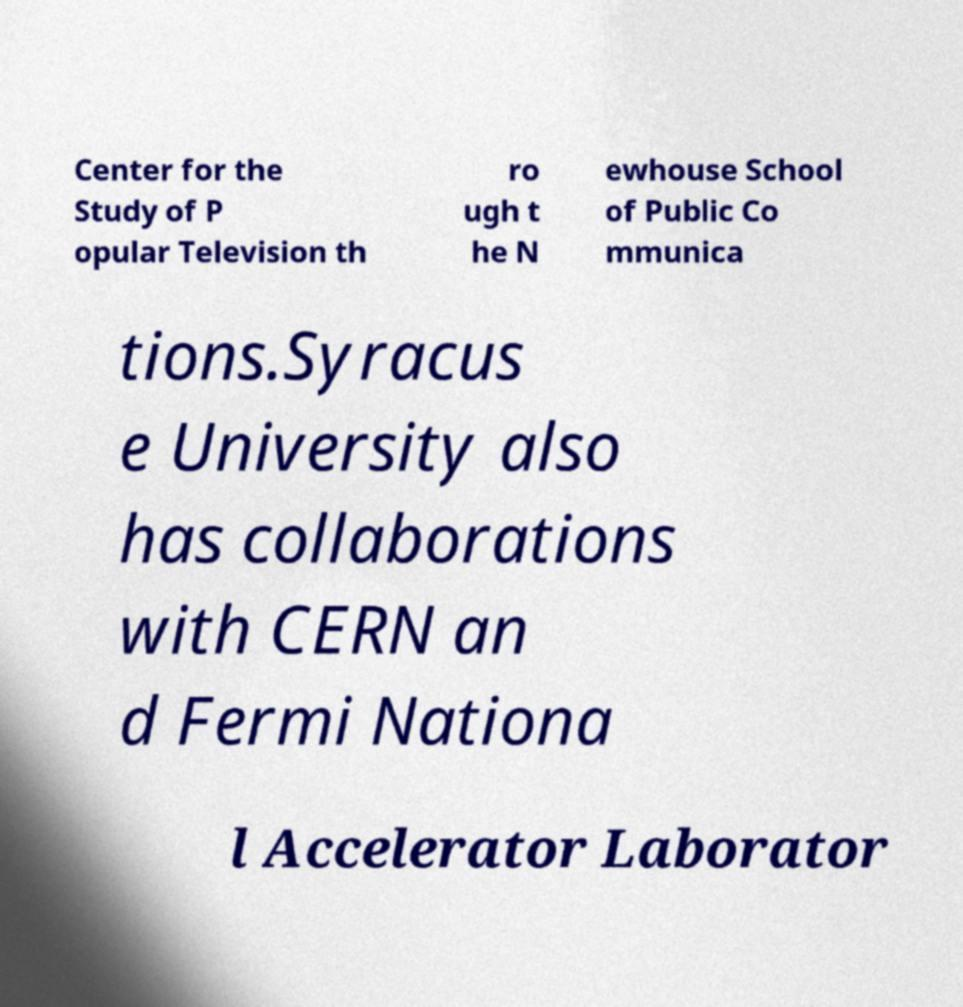I need the written content from this picture converted into text. Can you do that? Center for the Study of P opular Television th ro ugh t he N ewhouse School of Public Co mmunica tions.Syracus e University also has collaborations with CERN an d Fermi Nationa l Accelerator Laborator 